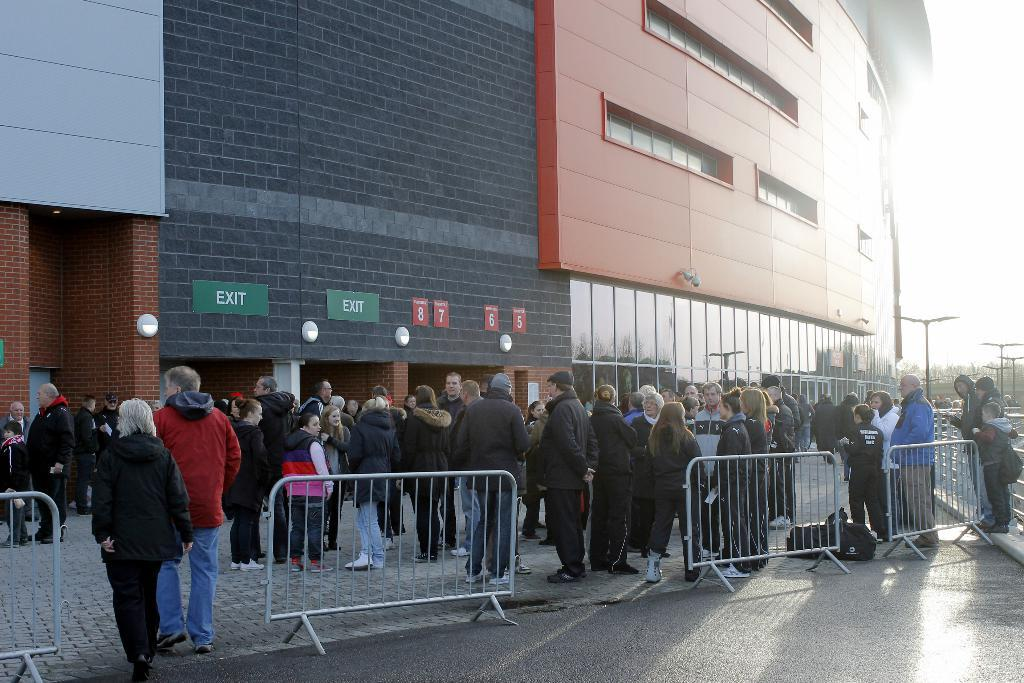What is the main subject in the center of the image? There are people in the center of the image. What type of structure can be seen at the top side of the image? There is a building at the top side of the image. What is present at the bottom side of the image? There is a boundary at the bottom side of the image. How many hydrants are visible in the image? There are no hydrants present in the image. What type of flowers can be seen growing near the people in the image? There are no flowers present in the image. 